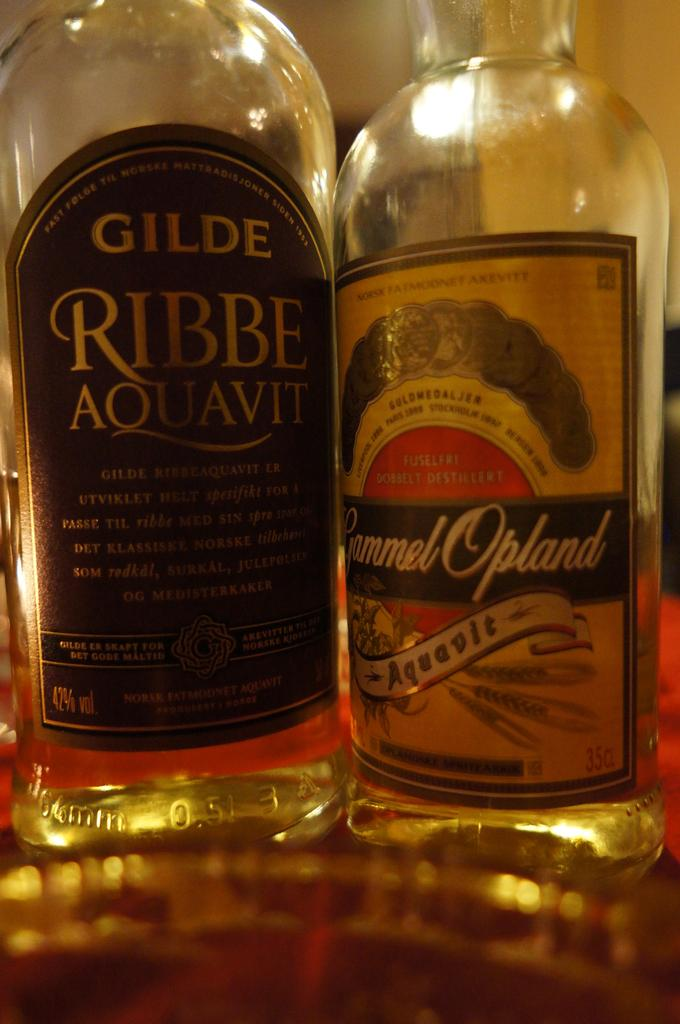Provide a one-sentence caption for the provided image. Two bottles next to each other of Aouavit. 